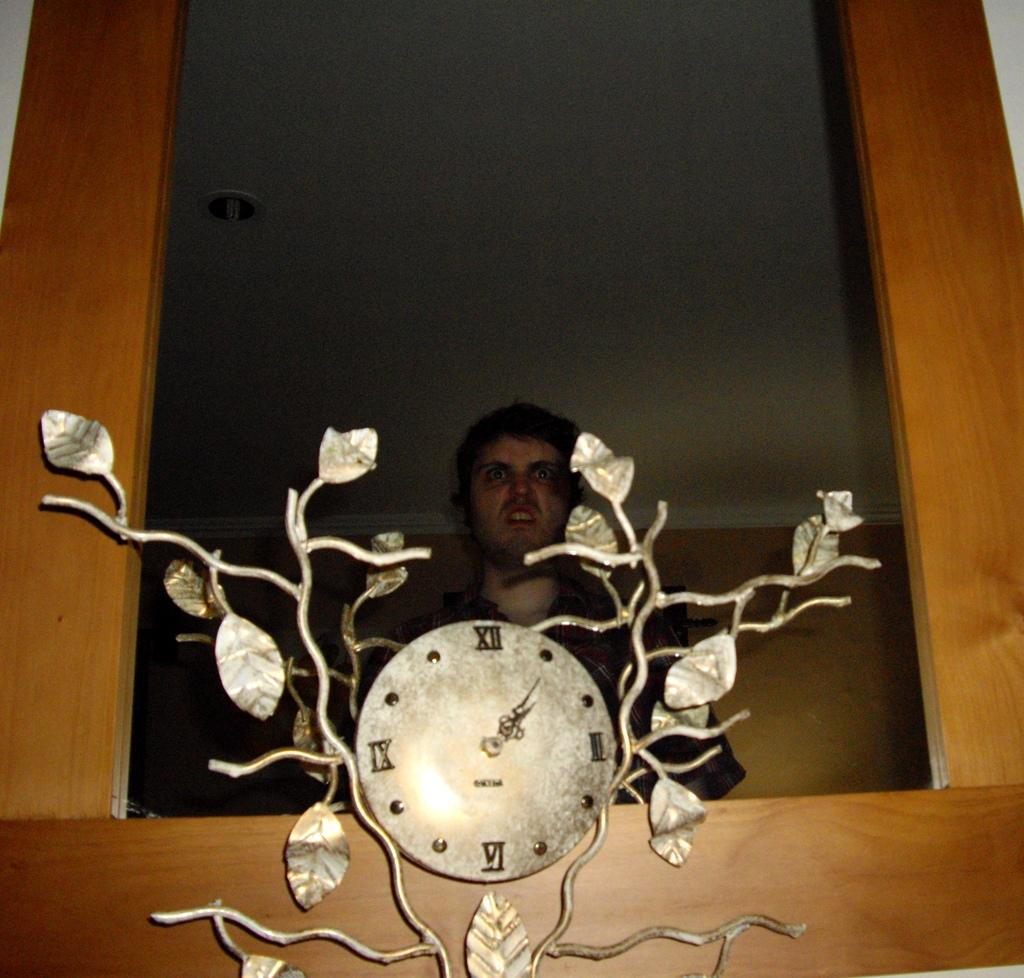<image>
Give a short and clear explanation of the subsequent image. A small tree-themed clock contains four Roman numerals, including XII and VI. 